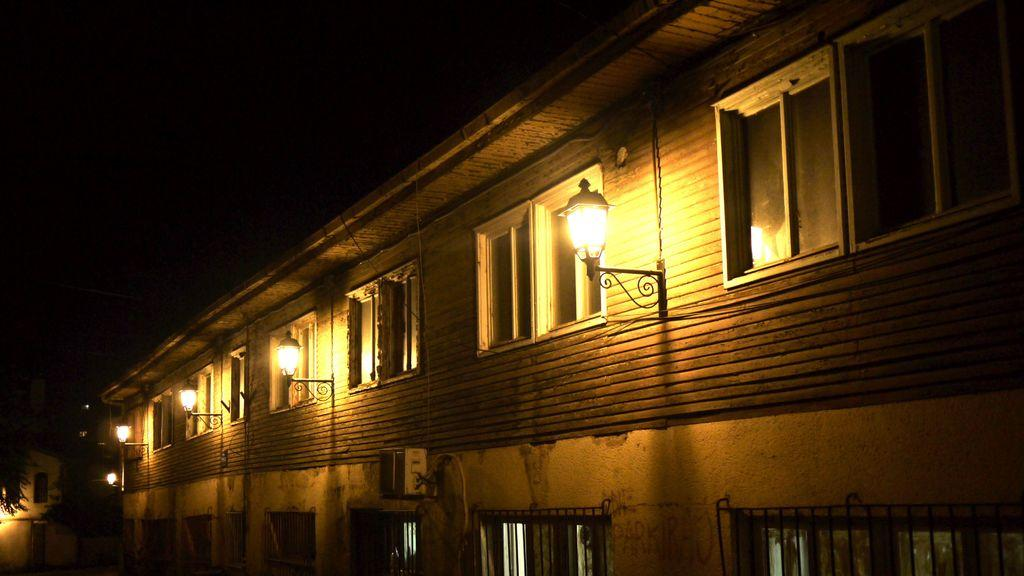What type of structure is visible in the image? There is a building in the image. What feature can be seen on the building? The building has windows. What objects are present in the image besides the building? There are stands and lights visible in the image. How would you describe the overall appearance of the image? The background of the image is dark. What is the tendency of the play in the image? There is no play present in the image; it features a building, stands, lights, and a dark background. What part of the building is used for partying in the image? There is no indication of a party or any specific part of the building being used for partying in the image. 